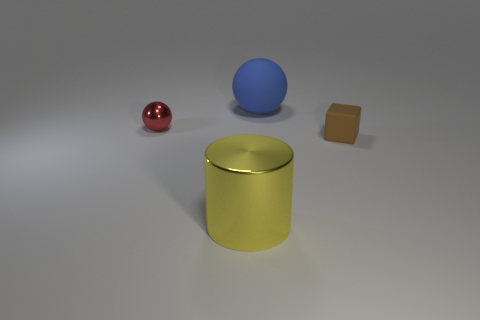Add 2 brown matte things. How many objects exist? 6 Subtract all metallic cylinders. Subtract all gray shiny cubes. How many objects are left? 3 Add 1 tiny red shiny things. How many tiny red shiny things are left? 2 Add 3 metal things. How many metal things exist? 5 Subtract 0 yellow spheres. How many objects are left? 4 